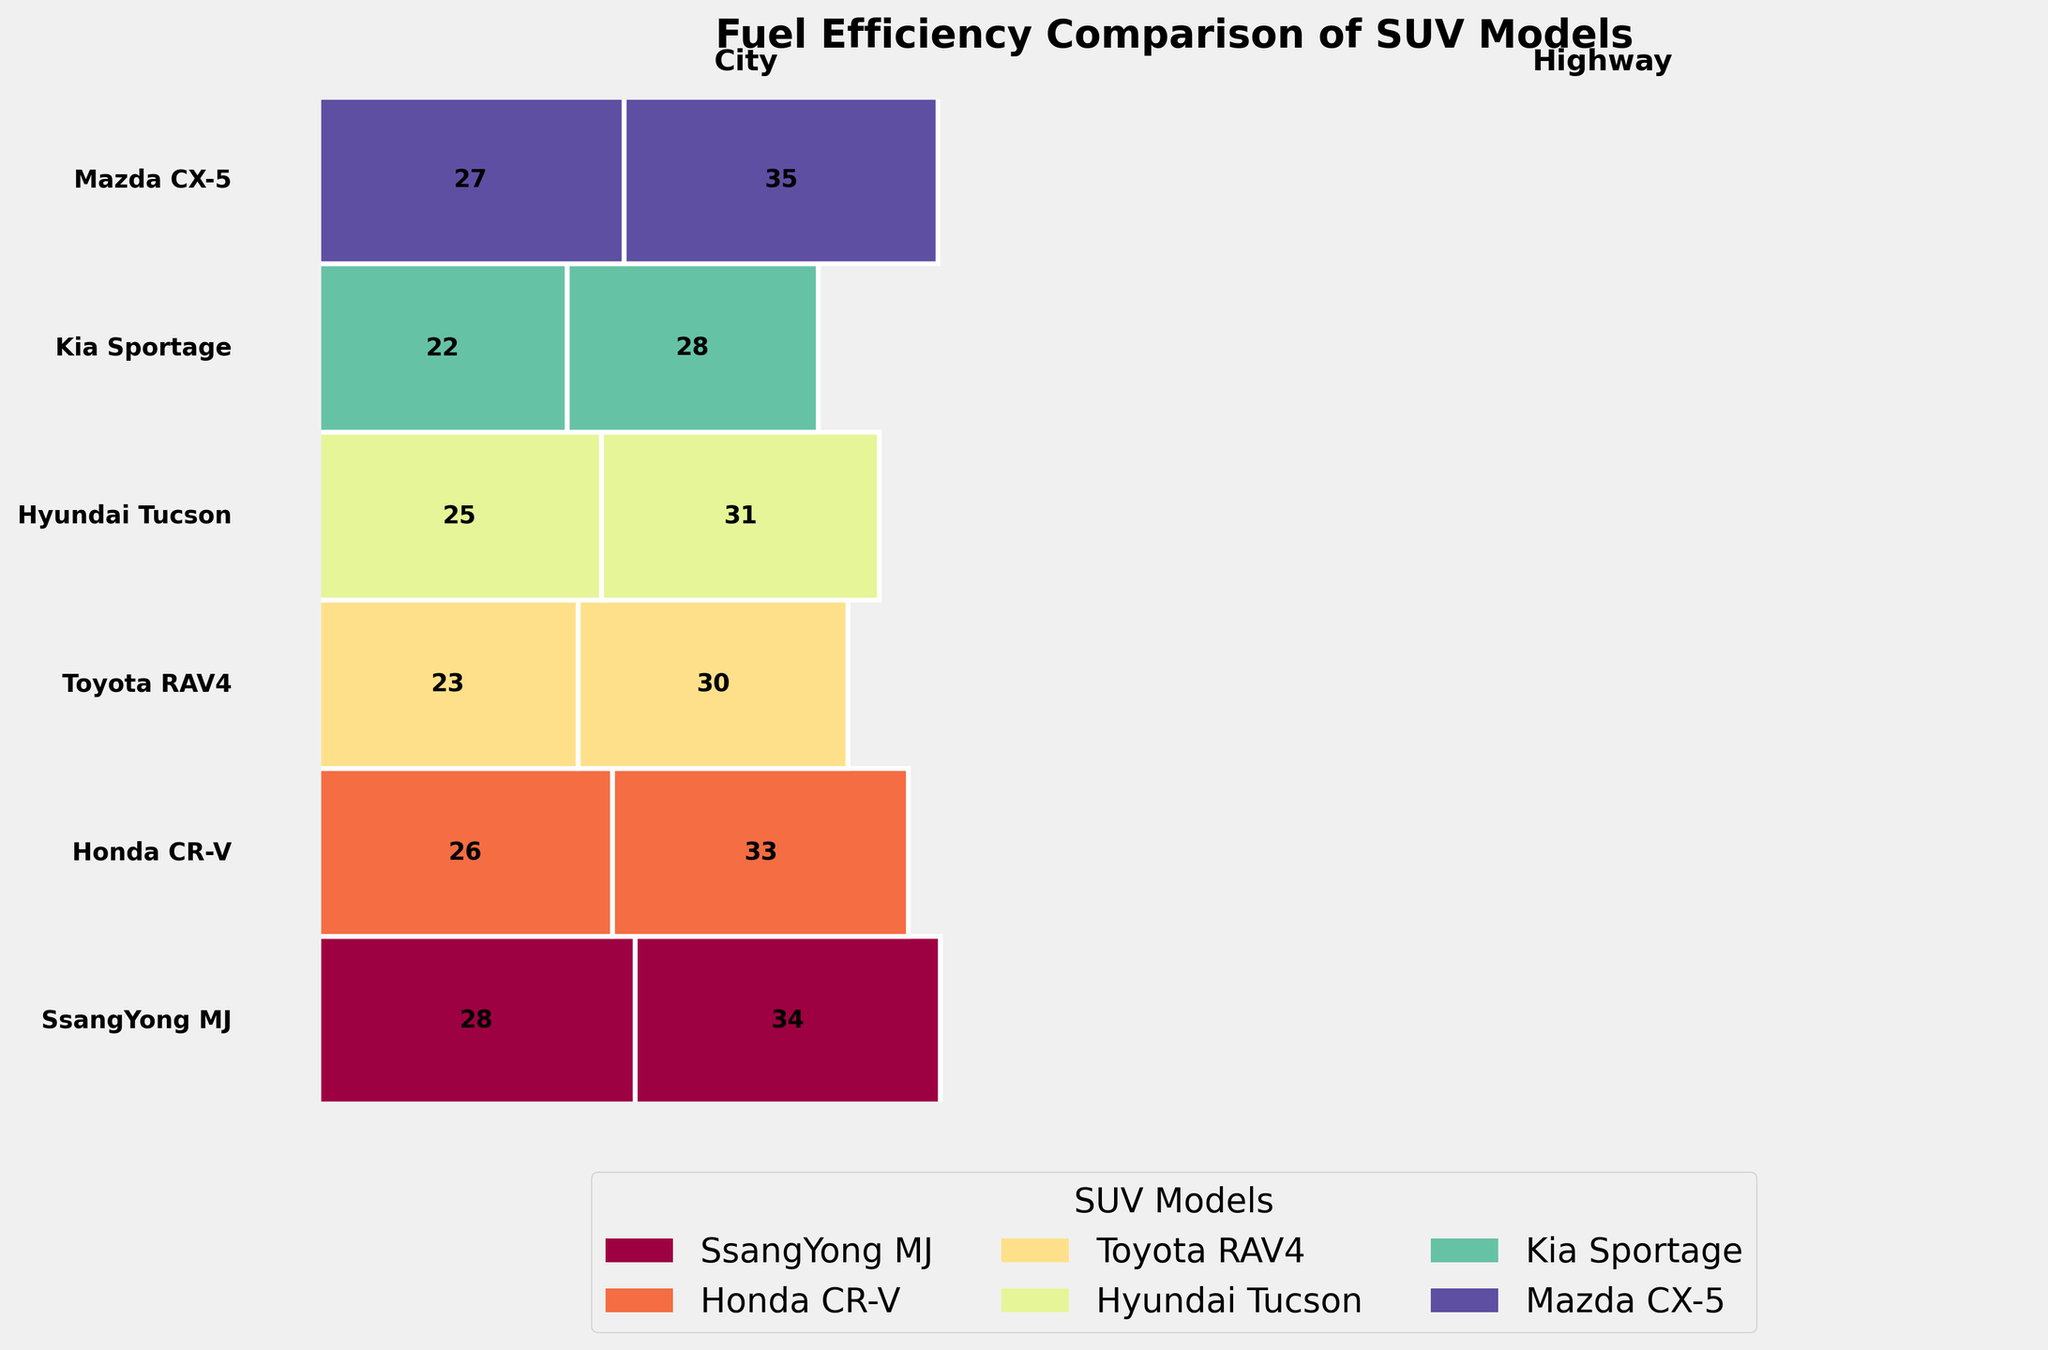What is the title of the plot? The title is clearly displayed at the top of the plot in larger and bold font.
Answer: Fuel Efficiency Comparison of SUV Models Which SUV model has the highest fuel efficiency on the highway? Look at the highway driving section of the plot and identify the model occupying the largest width proportional to fuel efficiency. The model is labeled on the left side of the plot.
Answer: Toyota RAV4 How does the SsangYong MJ’s city fuel efficiency compare to the Kia Sportage’s? Locate both SsangYong MJ and Kia Sportage in the city driving section and compare their values. SsangYong MJ shows a value of 22 and Kia Sportage shows a 23.
Answer: SsangYong MJ is slightly lower What is the average highway fuel efficiency of the top three performing SUVs in that category? Identify the top three models in highway driving section, which are Honda CR-V (34), Toyota RAV4 (35), and Hyundai Tucson (33). The average is calculated as (34 + 35 + 33) / 3.
Answer: 34 Which SUV has the lowest overall fuel efficiency, considering both city and highway? Compare the smallest areas in the plot for both driving types. SsangYong MJ has the smallest areas with values 22 (City) and 28 (Highway), making its overall average the lowest.
Answer: SsangYong MJ What are the total fuel efficiency values for the Mazda CX-5 for both city and highway driving? Locate Mazda CX-5 in both sections and sum the values: City (25) and Highway (31). Total is 25 + 31 = 56.
Answer: 56 Which model shows more improvement in fuel efficiency when switching from city to highway driving? For each model, calculate the difference between highway and city values, focusing on absolute improvements. The SsangYong MJ moves from 22 to 28, an increase of 6, whereas other models generally show smaller differences.
Answer: SsangYong MJ How many SUV models, in total, are compared in this plot? Identify the number of unique models listed on the left side of the plot. There are SsangYong MJ, Honda CR-V, Toyota RAV4, Hyundai Tucson, Kia Sportage, and Mazda CX-5.
Answer: 6 models What consistency can you observe in the fuel efficiency patterns of these SUVs across city and highway driving? Analyzing the width and values of each model in both sections shows that higher fuel efficiencies in city driving also generally translate to higher efficiencies in highway driving, though the degree of increase varies.
Answer: Higher efficiency in city often means higher in highway 